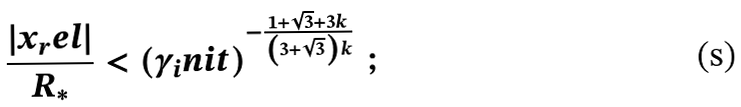<formula> <loc_0><loc_0><loc_500><loc_500>\frac { | x _ { r } e l | } { R _ { * } } < \left ( \gamma _ { i } n i t \right ) ^ { - \frac { 1 + \sqrt { 3 } + 3 k } { \left ( 3 + \sqrt { 3 } \right ) k } } \, ;</formula> 